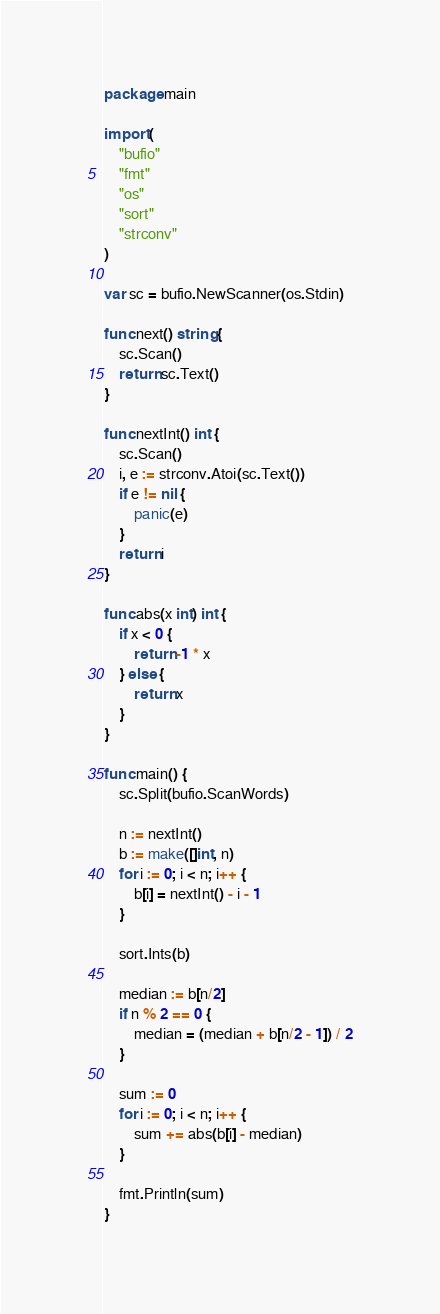Convert code to text. <code><loc_0><loc_0><loc_500><loc_500><_Go_>package main

import (
	"bufio"
	"fmt"
	"os"
	"sort"
	"strconv"
)

var sc = bufio.NewScanner(os.Stdin)

func next() string {
	sc.Scan()
	return sc.Text()
}

func nextInt() int {
	sc.Scan()
	i, e := strconv.Atoi(sc.Text())
	if e != nil {
		panic(e)
	}
	return i
}

func abs(x int) int {
	if x < 0 {
		return -1 * x
	} else {
		return x
	}
}

func main() {
	sc.Split(bufio.ScanWords)

	n := nextInt()
	b := make([]int, n)
	for i := 0; i < n; i++ {
		b[i] = nextInt() - i - 1
	}

	sort.Ints(b)

	median := b[n/2]
	if n % 2 == 0 {
		median = (median + b[n/2 - 1]) / 2
	}

	sum := 0
	for i := 0; i < n; i++ {
		sum += abs(b[i] - median)
	}

	fmt.Println(sum)
}</code> 